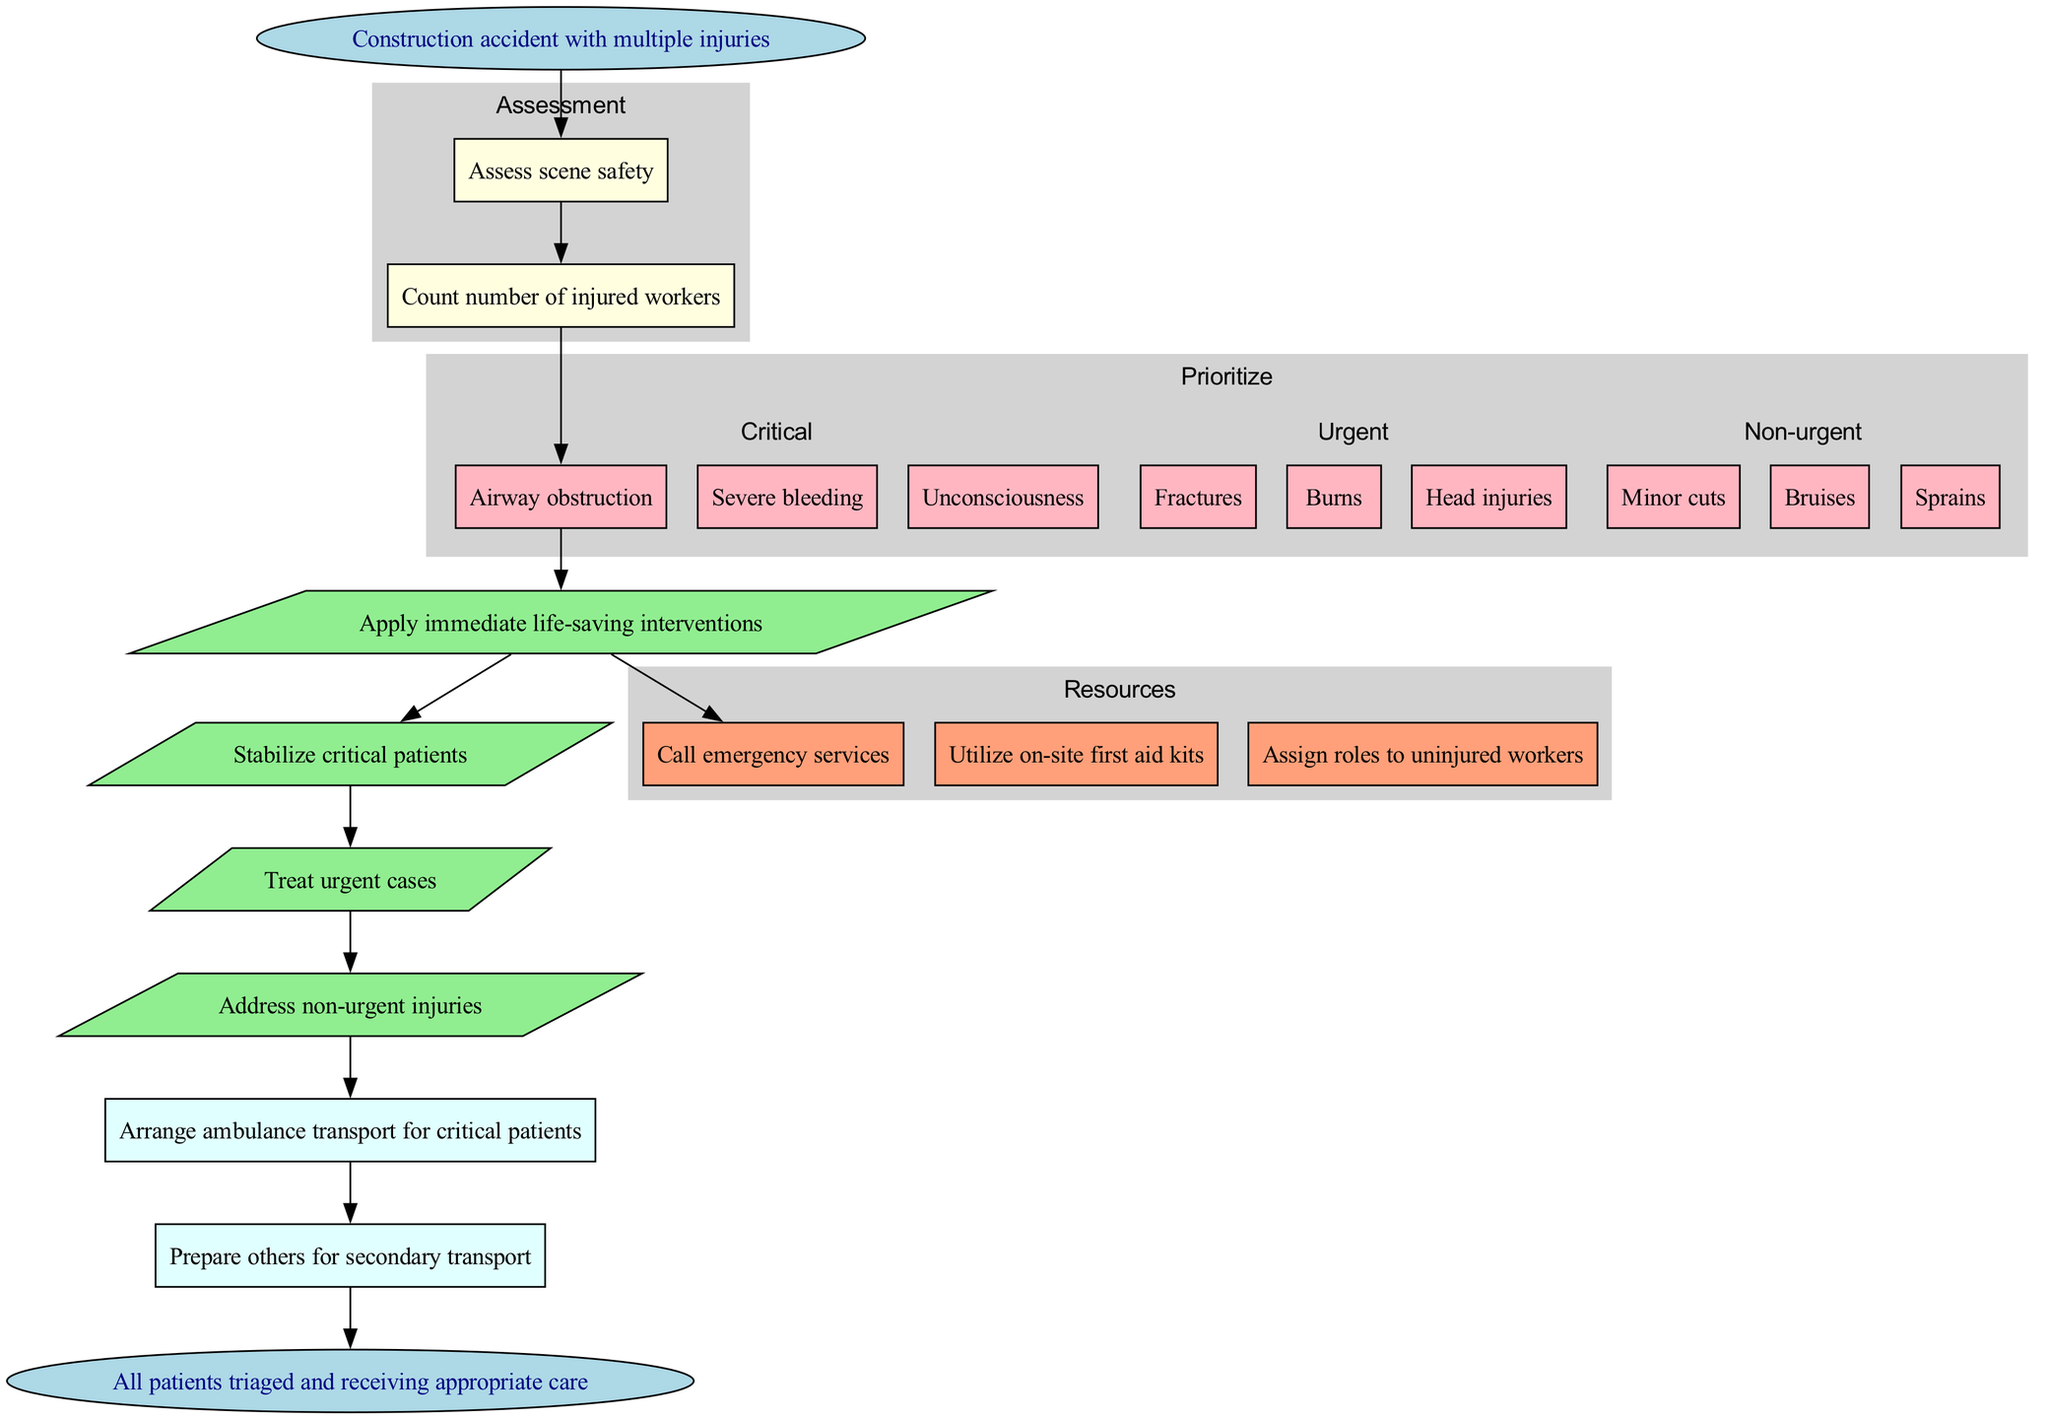What is the first step after the construction accident? The first step is to "Assess scene safety". This is directly from the diagram as it is the first action taken following the incident.
Answer: Assess scene safety How many injuries are categorized as critical? The critical injuries are "Airway obstruction", "Severe bleeding", and "Unconsciousness". There are three items in this category based on the diagram's enumeration.
Answer: 3 Which step follows the assessment of the number of injured workers? The next step after assessing the number of injured workers is to address "Airway obstruction", which is the first critical injury that is indicated to be prioritized.
Answer: Airway obstruction What type of node is used to represent actions in the flowchart? Actions in the flowchart are represented using parallelograms, which differentiates them from other node shapes like boxes and ellipses.
Answer: Parallelogram Which action is taken first for critical patients? The first action taken for critical patients is "Apply immediate life-saving interventions". It is the first action in the sequence for critical care following prioritization.
Answer: Apply immediate life-saving interventions What do the resources section indicate is needed? The resources section includes "Call emergency services", "Utilize on-site first aid kits", and "Assign roles to uninjured workers". This means that resources are essential for handling the situation effectively.
Answer: Call emergency services If a critical patient is involved, what transport action is taken? The transport action for critical patients is "Arrange ambulance transport for critical patients", which denotes the urgency needed for their care based on their injuries.
Answer: Arrange ambulance transport for critical patients Which type of injuries is treated after critical ones? After treating critical injuries, the urgent cases such as "Fractures", "Burns", and "Head injuries" are addressed. This indicates a prioritized flow for injury treatment.
Answer: Urgent cases How many transport actions are indicated in the flowchart? There are two transport actions indicated: "Arrange ambulance transport for critical patients" and "Prepare others for secondary transport", totaling two distinct transport actions mentioned.
Answer: 2 